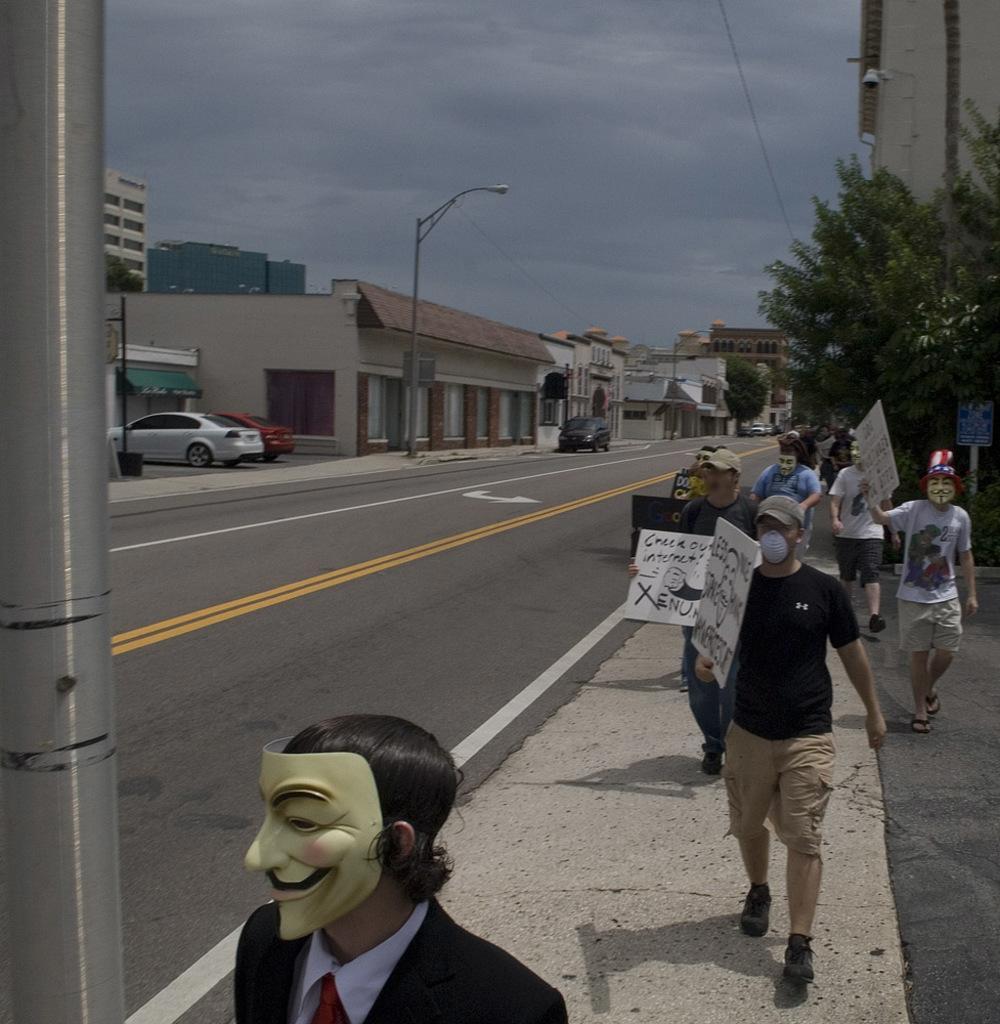How would you summarize this image in a sentence or two? This is an outside view. On the right side there are few people wearing masks to their faces, holding boards in the hands and walking. On the left side there are few cars on the road. On both sides of the road there are light poles, trees and buildings. At the top of the image I can see the sky and clouds. 